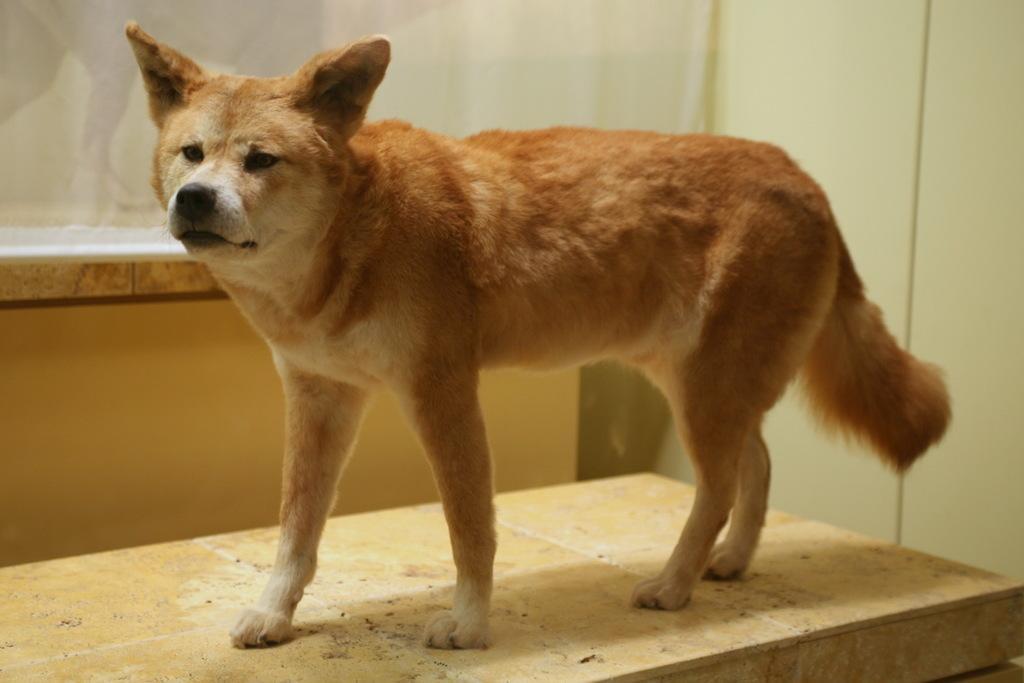Can you describe this image briefly? This is a dog standing. In the background, I think this is a glass door. On the right side of the image, that looks like a wall. 